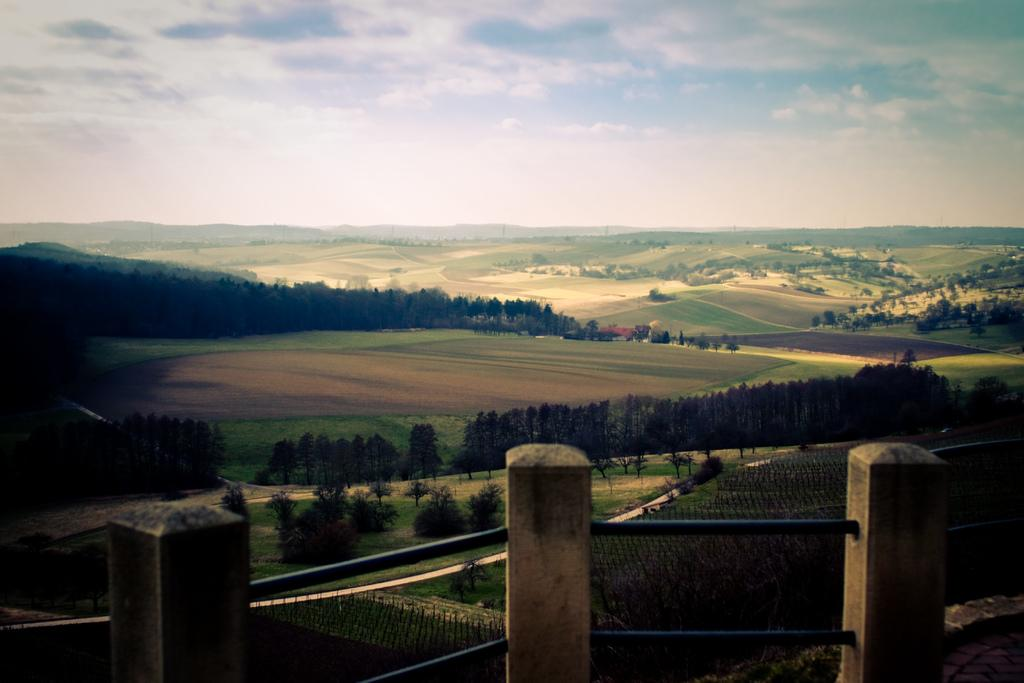What can be seen in the image that resembles a structure? There are three poles with rods attached to them in the image. What type of natural environment is visible in the background of the image? There are trees and meadows in the background of the image. What part of the natural environment is visible in the sky? The sky is visible in the background of the image. What type of hose can be seen in the image? There is no hose present in the image. How many people are in the crowd in the image? There is no crowd present in the image. 